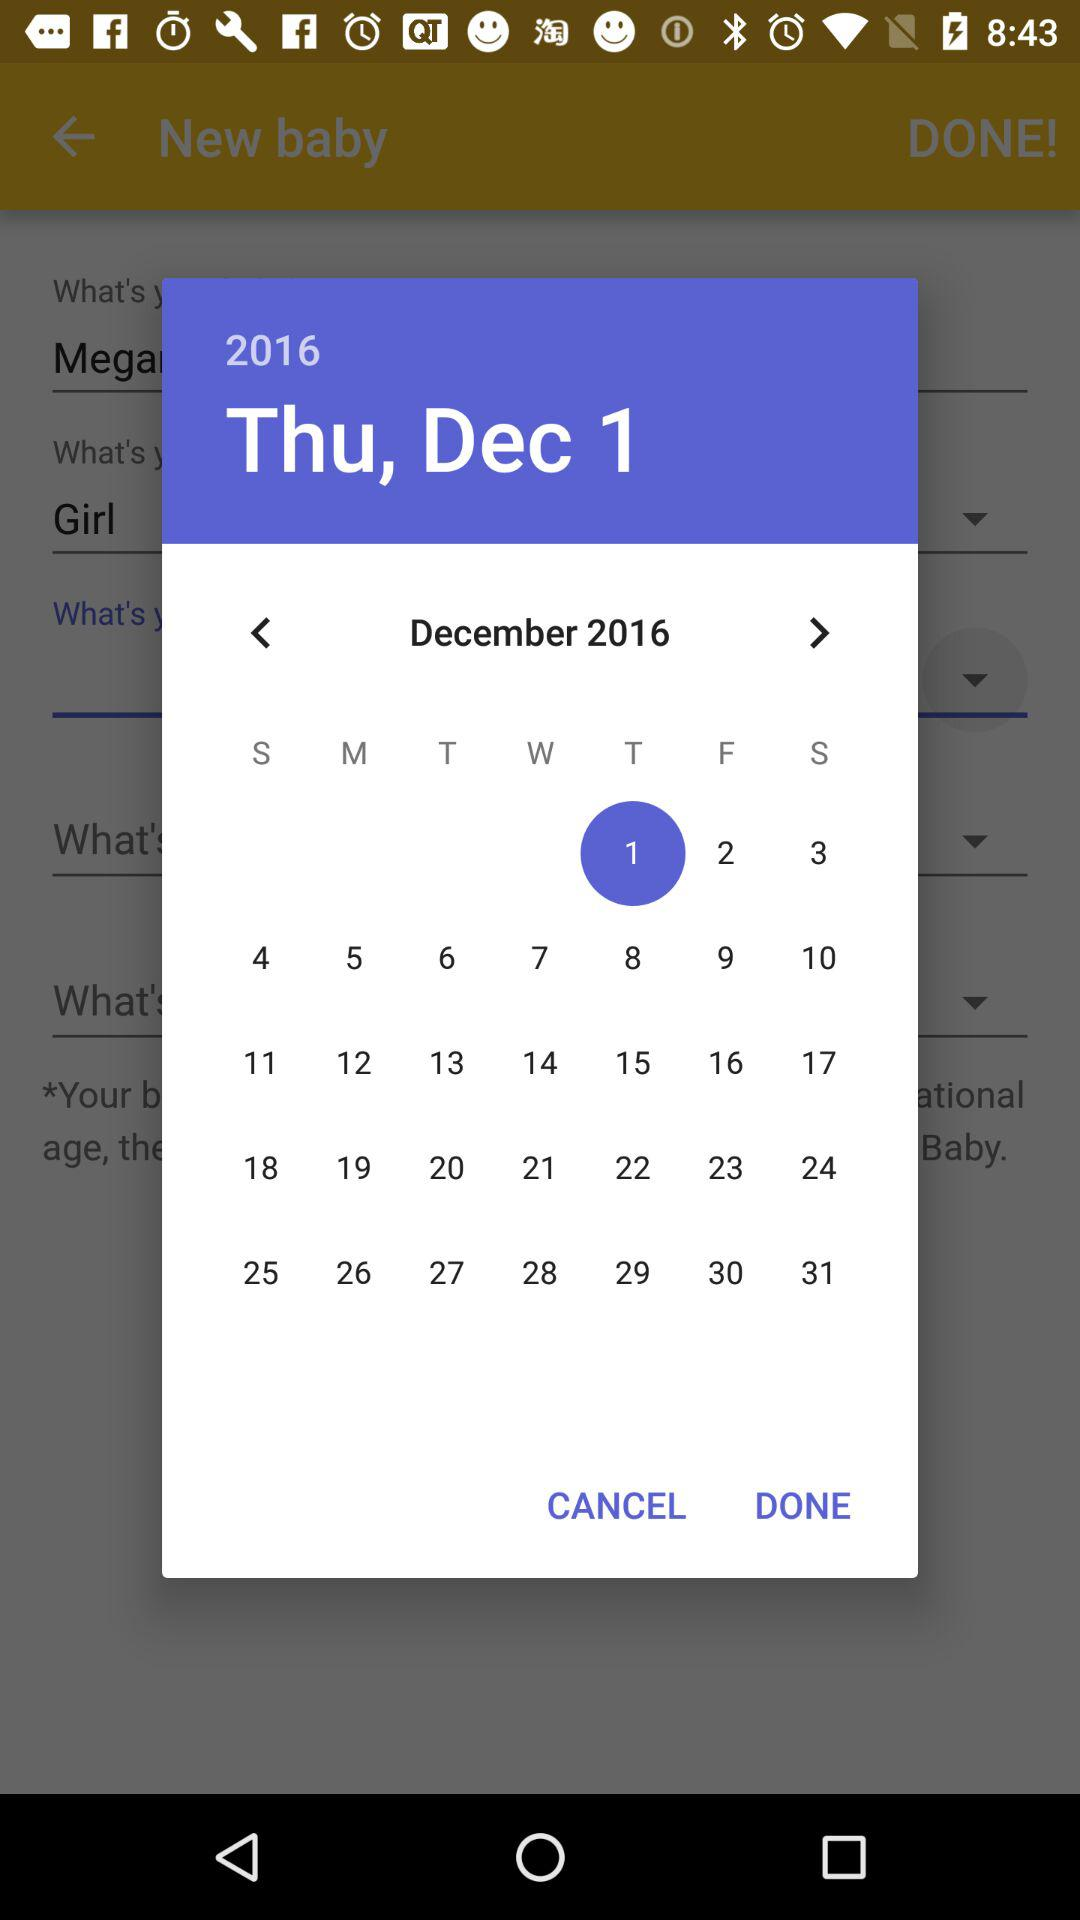What's the year selected on the calendar? The selected year is 2016. 